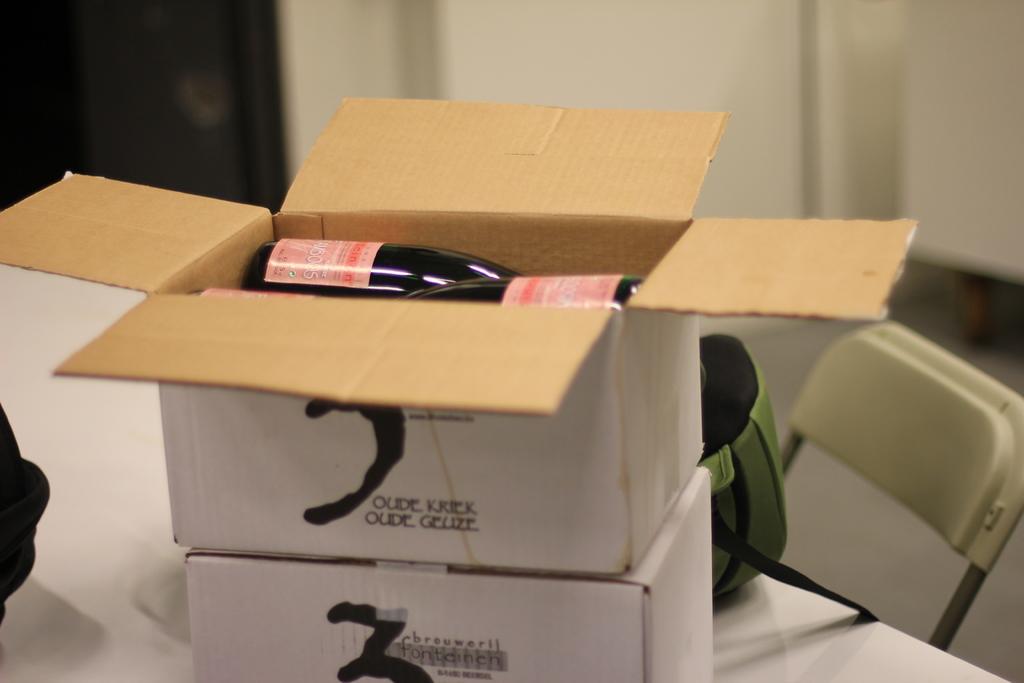What does the box say?
Make the answer very short. Oude kriek. What color is the text on the box?
Make the answer very short. Black. 